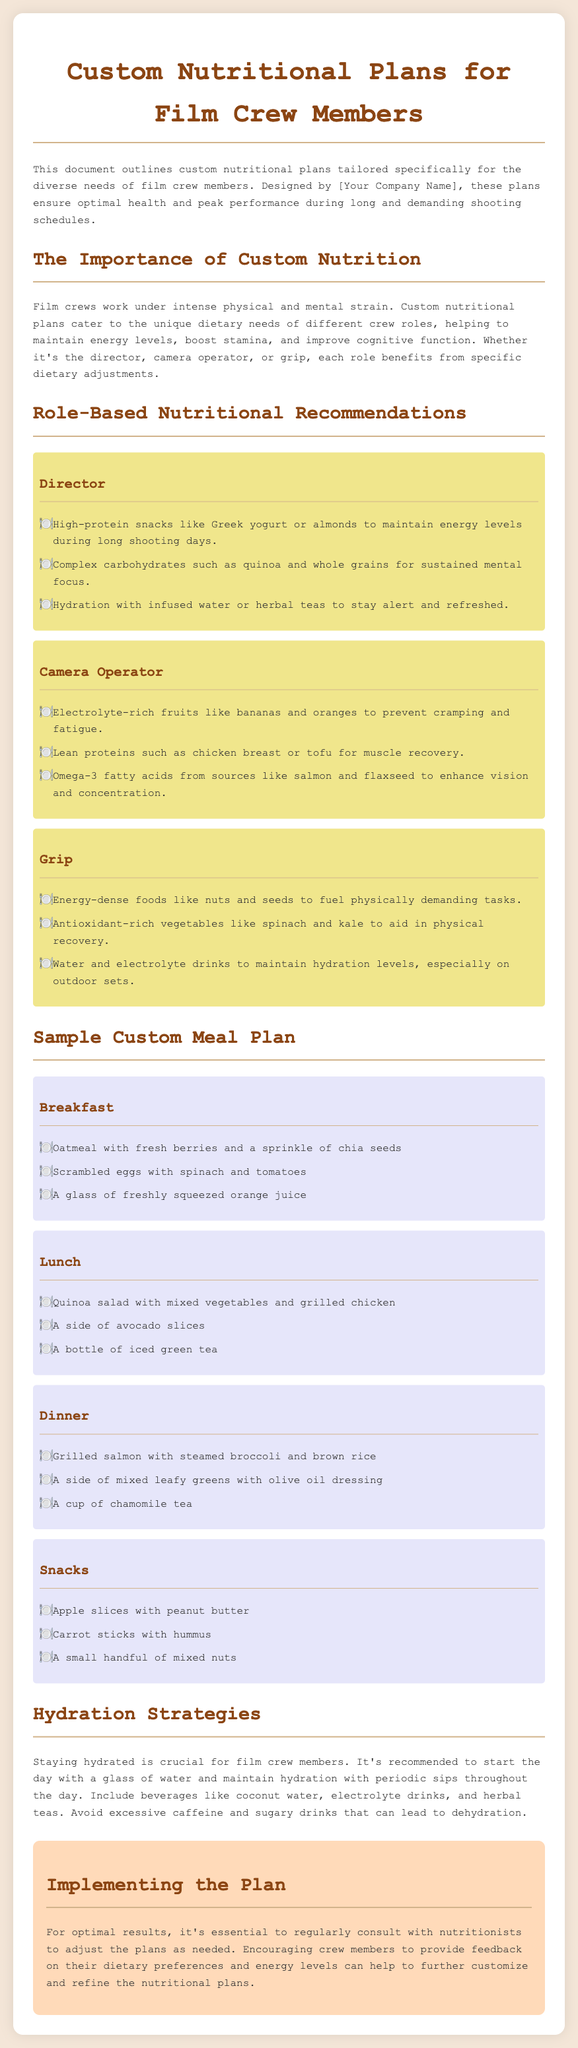What is the title of the document? The title of the document is provided at the beginning and mentions "Custom Nutritional Plans for Film Crew Members."
Answer: Custom Nutritional Plans for Film Crew Members Who are the nutritional plans designed for? The document specifies that the nutritional plans are tailored specifically for film crew members.
Answer: Film crew members Which role recommends high-protein snacks? The document lists "Director" as the role that recommends high-protein snacks like Greek yogurt or almonds.
Answer: Director What is included in the sample breakfast meal plan? The document outlines various items in the breakfast meal plan, including oatmeal with fresh berries.
Answer: Oatmeal with fresh berries What is one hydration recommendation mentioned? The document suggests starting the day with a glass of water as part of hydration strategies.
Answer: A glass of water What type of foods should grips consume? The document suggests that grips should consume energy-dense foods like nuts and seeds.
Answer: Energy-dense foods How many meals are included in the sample meal plan? The document presents a structured meal plan consisting of four distinct meals.
Answer: Four What beverage is recommended for the lunch meal? The document suggests iced green tea as the beverage for the lunch meal.
Answer: Iced green tea What should be the first step for optimal results according to the conclusion? The document emphasizes the need for regular consultations with nutritionists to adjust plans as needed.
Answer: Consult with nutritionists 